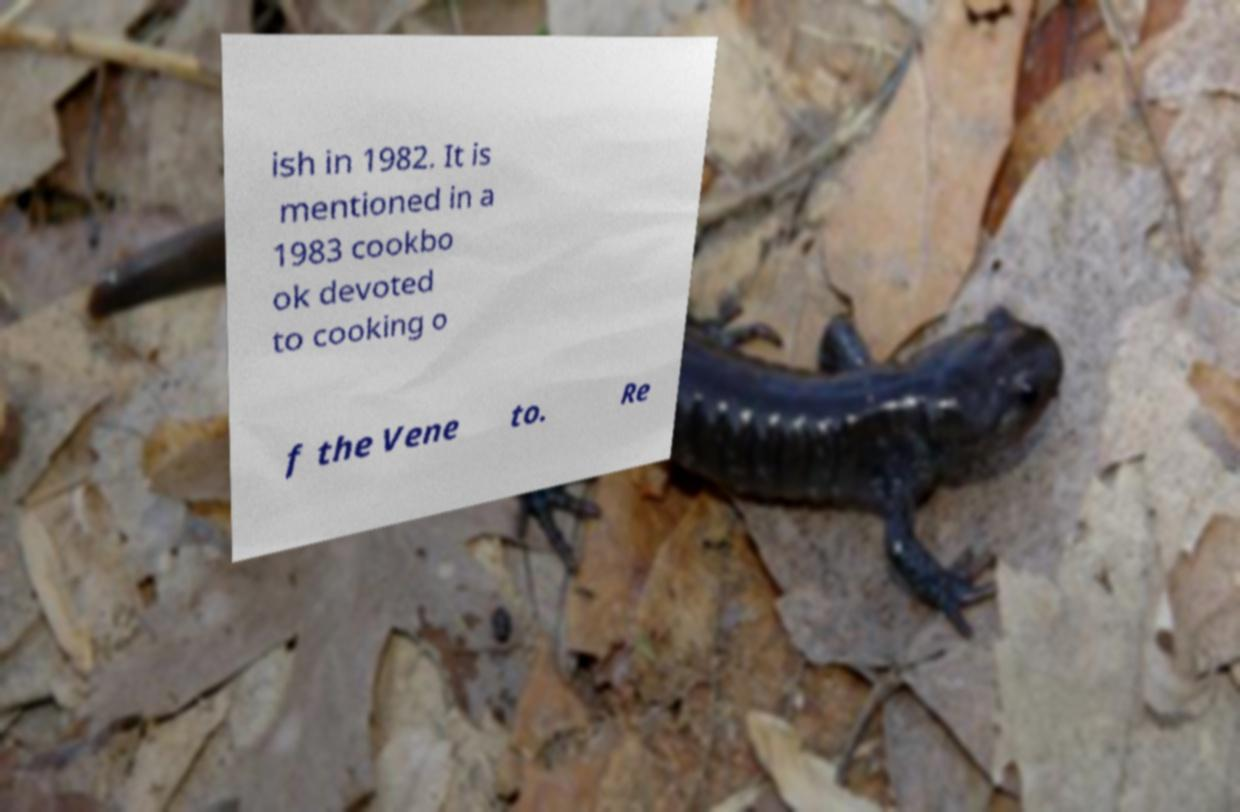For documentation purposes, I need the text within this image transcribed. Could you provide that? ish in 1982. It is mentioned in a 1983 cookbo ok devoted to cooking o f the Vene to. Re 